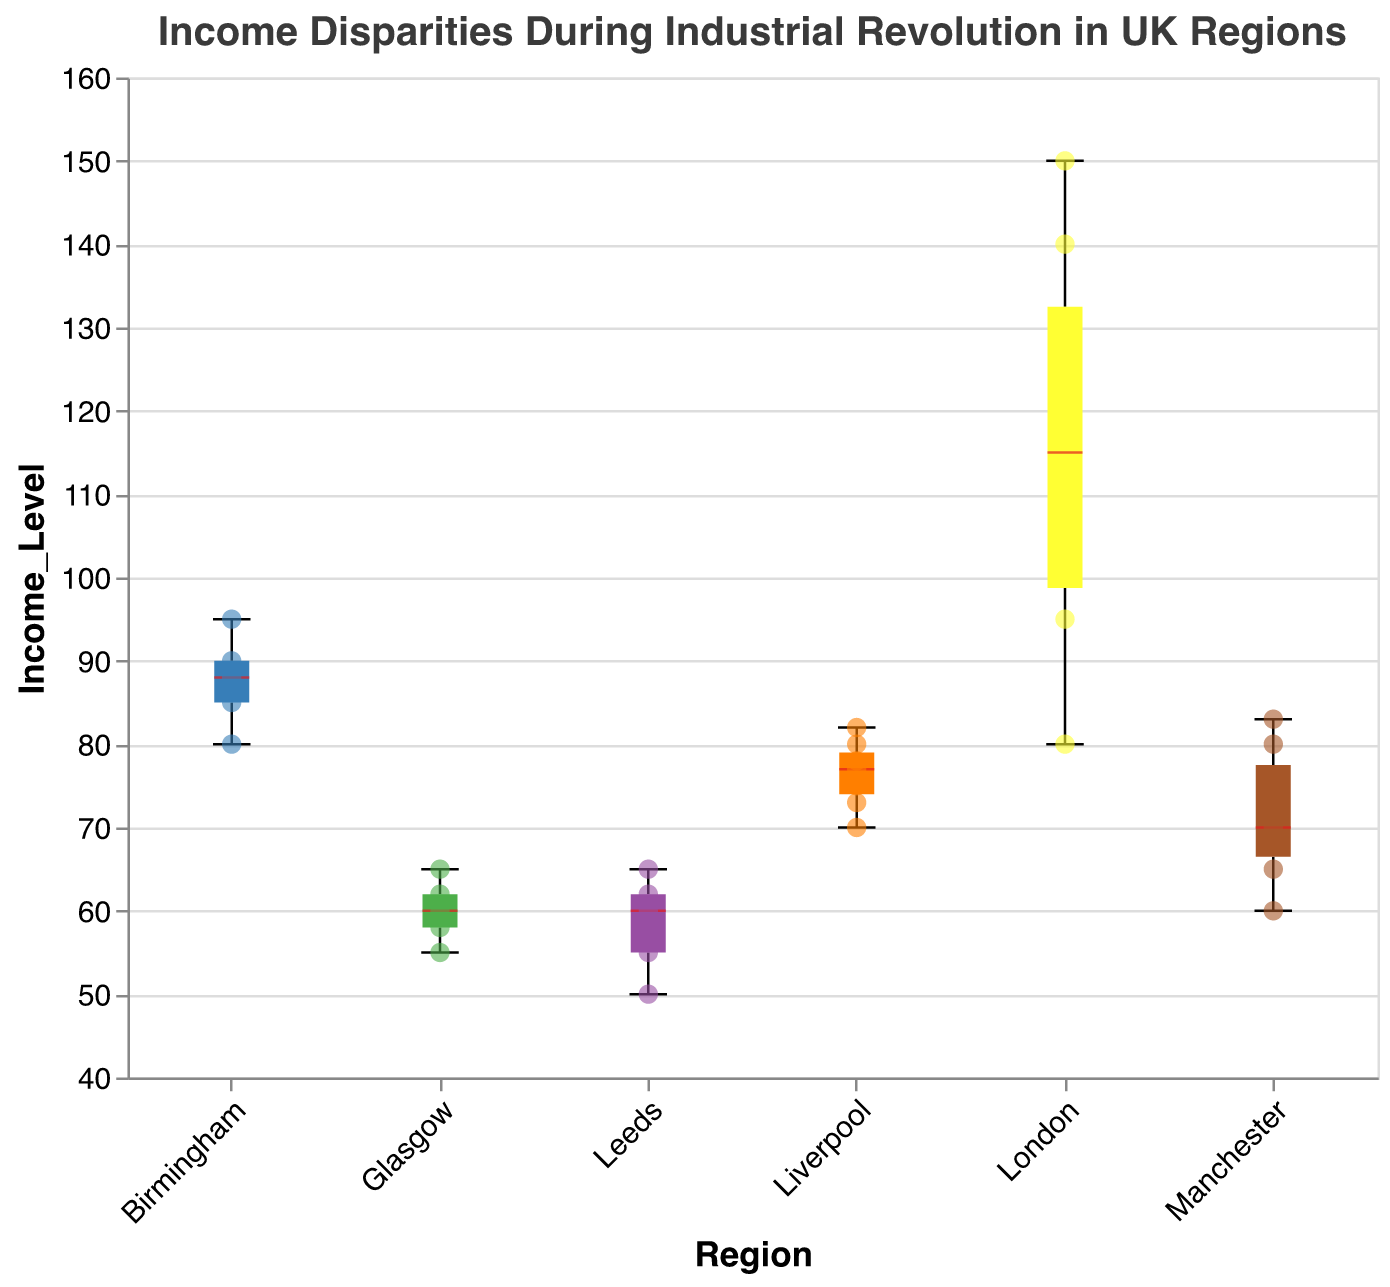What is the overall highest income level in the dataset? The overall highest income level can be determined by looking at all the data points across the different regions. The highest value among all these points is 150, which is in the London region.
Answer: 150 Which region has the widest interquartile range (IQR) of income levels? To determine the widest IQR, we need to compare the range between the upper quartile (75th percentile) and lower quartile (25th percentile) for each region. Based on the box plots, London has a visibly wider box, indicating it has the widest IQR.
Answer: London What is the median income level in Birmingham? To find the median, look at the middle line in the box of the Birmingham region. The median value is around 88.
Answer: 88 How does the median income level of London compare to that of Leeds? The median line in the London box plot is higher than the median line in the Leeds box plot. London's median is around 115, while Leeds's median is around 60.
Answer: London has a higher median income level than Leeds Which region has the smallest range between its minimum and maximum income levels? The smallest range is identified by observing the length of the whiskers (minimum to maximum) in the box plots. Leeds has the smallest range with incomes varying from 50 to 65.
Answer: Leeds Is Manchester's upper quartile higher than Birmingham's median? The upper quartile for Manchester can be found at the top of the box for Manchester, around 75. Birmingham's median is around 88, which is higher.
Answer: No Which region has the densest clustering of income levels around the median? The density can be assessed by the concentration of scatter points around the median line. Liverpool has a dense clustering with many points close to its median.
Answer: Liverpool What is the lowest observed income level in Glasgow? By identifying the lowest point of the lower whisker in the Glasgow box plot, it is observed at 55.
Answer: 55 Between Liverpool and Manchester, which region shows greater variability in income levels? Variability can be measured by comparing the lengths of the boxes and whiskers. Manchester shows a wider box and longer whiskers than Liverpool, indicating greater variability.
Answer: Manchester Is there a region with no outlier points? If so, which one(s)? Regions without outliers are indicated by the absence of *distinct points* beyond the whiskers. Birmingham and Glasgow have no separate outlier points.
Answer: Birmingham and Glasgow 